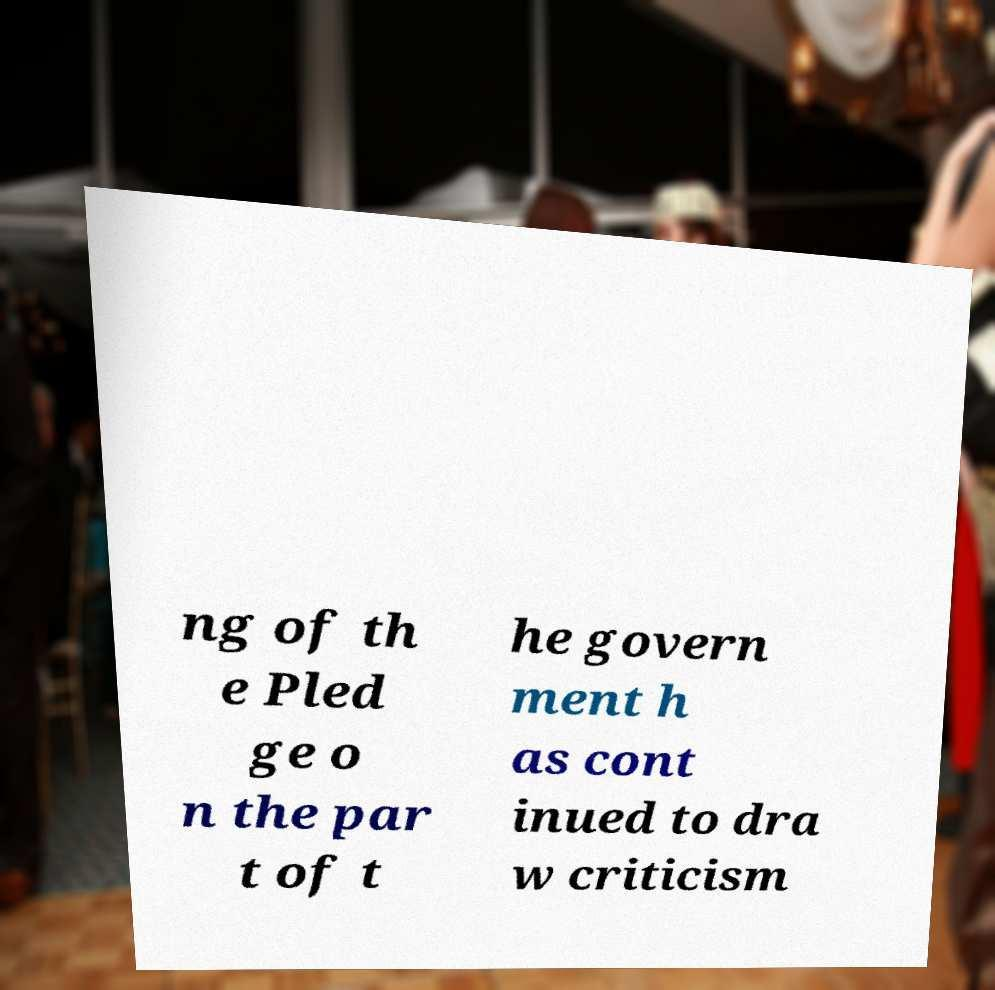I need the written content from this picture converted into text. Can you do that? ng of th e Pled ge o n the par t of t he govern ment h as cont inued to dra w criticism 